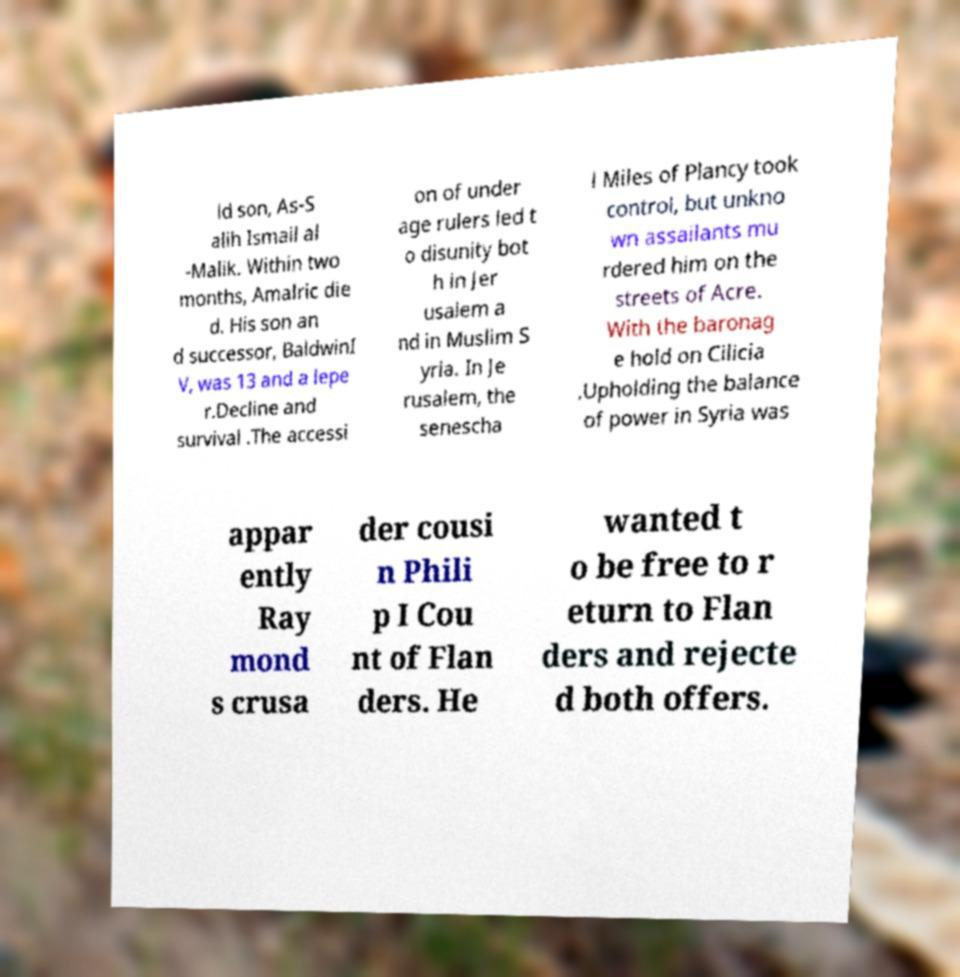Could you assist in decoding the text presented in this image and type it out clearly? ld son, As-S alih Ismail al -Malik. Within two months, Amalric die d. His son an d successor, BaldwinI V, was 13 and a lepe r.Decline and survival .The accessi on of under age rulers led t o disunity bot h in Jer usalem a nd in Muslim S yria. In Je rusalem, the senescha l Miles of Plancy took control, but unkno wn assailants mu rdered him on the streets of Acre. With the baronag e hold on Cilicia .Upholding the balance of power in Syria was appar ently Ray mond s crusa der cousi n Phili p I Cou nt of Flan ders. He wanted t o be free to r eturn to Flan ders and rejecte d both offers. 